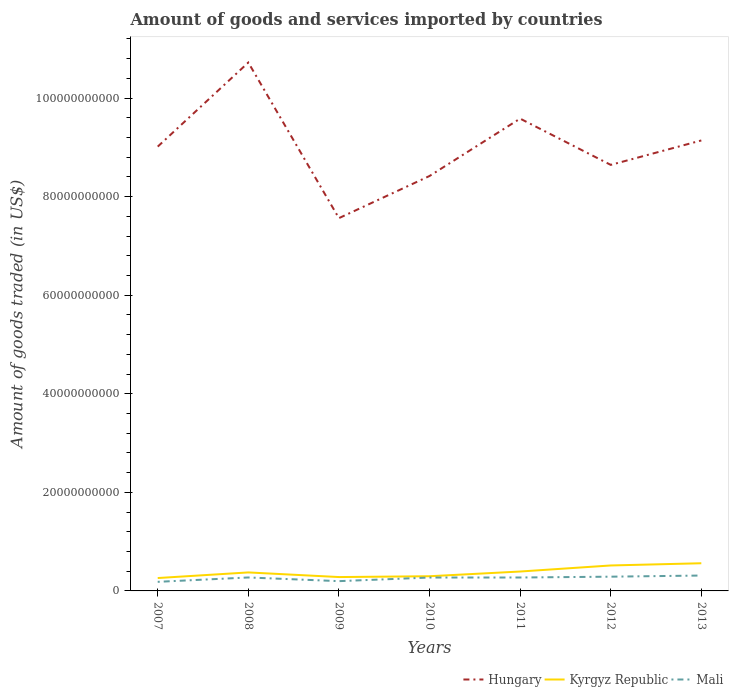How many different coloured lines are there?
Offer a terse response. 3. Does the line corresponding to Kyrgyz Republic intersect with the line corresponding to Mali?
Your response must be concise. No. Is the number of lines equal to the number of legend labels?
Ensure brevity in your answer.  Yes. Across all years, what is the maximum total amount of goods and services imported in Kyrgyz Republic?
Ensure brevity in your answer.  2.61e+09. In which year was the total amount of goods and services imported in Kyrgyz Republic maximum?
Ensure brevity in your answer.  2007. What is the total total amount of goods and services imported in Hungary in the graph?
Offer a very short reply. -1.16e+1. What is the difference between the highest and the second highest total amount of goods and services imported in Mali?
Provide a succinct answer. 1.28e+09. Is the total amount of goods and services imported in Mali strictly greater than the total amount of goods and services imported in Kyrgyz Republic over the years?
Your response must be concise. Yes. How many lines are there?
Provide a short and direct response. 3. What is the difference between two consecutive major ticks on the Y-axis?
Keep it short and to the point. 2.00e+1. Where does the legend appear in the graph?
Your answer should be compact. Bottom right. How are the legend labels stacked?
Provide a succinct answer. Horizontal. What is the title of the graph?
Your answer should be very brief. Amount of goods and services imported by countries. What is the label or title of the X-axis?
Give a very brief answer. Years. What is the label or title of the Y-axis?
Provide a short and direct response. Amount of goods traded (in US$). What is the Amount of goods traded (in US$) of Hungary in 2007?
Ensure brevity in your answer.  9.02e+1. What is the Amount of goods traded (in US$) of Kyrgyz Republic in 2007?
Provide a succinct answer. 2.61e+09. What is the Amount of goods traded (in US$) of Mali in 2007?
Make the answer very short. 1.84e+09. What is the Amount of goods traded (in US$) of Hungary in 2008?
Your answer should be compact. 1.07e+11. What is the Amount of goods traded (in US$) of Kyrgyz Republic in 2008?
Keep it short and to the point. 3.75e+09. What is the Amount of goods traded (in US$) of Mali in 2008?
Offer a terse response. 2.73e+09. What is the Amount of goods traded (in US$) in Hungary in 2009?
Offer a terse response. 7.56e+1. What is the Amount of goods traded (in US$) in Kyrgyz Republic in 2009?
Your answer should be compact. 2.81e+09. What is the Amount of goods traded (in US$) in Mali in 2009?
Your response must be concise. 1.98e+09. What is the Amount of goods traded (in US$) in Hungary in 2010?
Offer a terse response. 8.42e+1. What is the Amount of goods traded (in US$) of Kyrgyz Republic in 2010?
Provide a short and direct response. 2.98e+09. What is the Amount of goods traded (in US$) of Mali in 2010?
Your response must be concise. 2.72e+09. What is the Amount of goods traded (in US$) of Hungary in 2011?
Provide a short and direct response. 9.58e+1. What is the Amount of goods traded (in US$) of Kyrgyz Republic in 2011?
Your answer should be very brief. 3.94e+09. What is the Amount of goods traded (in US$) in Mali in 2011?
Your answer should be very brief. 2.72e+09. What is the Amount of goods traded (in US$) of Hungary in 2012?
Your response must be concise. 8.65e+1. What is the Amount of goods traded (in US$) of Kyrgyz Republic in 2012?
Your answer should be compact. 5.17e+09. What is the Amount of goods traded (in US$) in Mali in 2012?
Make the answer very short. 2.89e+09. What is the Amount of goods traded (in US$) in Hungary in 2013?
Keep it short and to the point. 9.14e+1. What is the Amount of goods traded (in US$) of Kyrgyz Republic in 2013?
Provide a short and direct response. 5.61e+09. What is the Amount of goods traded (in US$) in Mali in 2013?
Your answer should be very brief. 3.12e+09. Across all years, what is the maximum Amount of goods traded (in US$) of Hungary?
Offer a very short reply. 1.07e+11. Across all years, what is the maximum Amount of goods traded (in US$) of Kyrgyz Republic?
Provide a short and direct response. 5.61e+09. Across all years, what is the maximum Amount of goods traded (in US$) of Mali?
Make the answer very short. 3.12e+09. Across all years, what is the minimum Amount of goods traded (in US$) in Hungary?
Offer a terse response. 7.56e+1. Across all years, what is the minimum Amount of goods traded (in US$) in Kyrgyz Republic?
Make the answer very short. 2.61e+09. Across all years, what is the minimum Amount of goods traded (in US$) in Mali?
Make the answer very short. 1.84e+09. What is the total Amount of goods traded (in US$) in Hungary in the graph?
Your answer should be very brief. 6.31e+11. What is the total Amount of goods traded (in US$) in Kyrgyz Republic in the graph?
Offer a very short reply. 2.69e+1. What is the total Amount of goods traded (in US$) of Mali in the graph?
Provide a short and direct response. 1.80e+1. What is the difference between the Amount of goods traded (in US$) in Hungary in 2007 and that in 2008?
Make the answer very short. -1.71e+1. What is the difference between the Amount of goods traded (in US$) of Kyrgyz Republic in 2007 and that in 2008?
Your response must be concise. -1.14e+09. What is the difference between the Amount of goods traded (in US$) in Mali in 2007 and that in 2008?
Offer a very short reply. -8.86e+08. What is the difference between the Amount of goods traded (in US$) of Hungary in 2007 and that in 2009?
Provide a short and direct response. 1.45e+1. What is the difference between the Amount of goods traded (in US$) of Kyrgyz Republic in 2007 and that in 2009?
Your answer should be compact. -2.00e+08. What is the difference between the Amount of goods traded (in US$) of Mali in 2007 and that in 2009?
Provide a succinct answer. -1.38e+08. What is the difference between the Amount of goods traded (in US$) of Hungary in 2007 and that in 2010?
Provide a short and direct response. 5.96e+09. What is the difference between the Amount of goods traded (in US$) in Kyrgyz Republic in 2007 and that in 2010?
Keep it short and to the point. -3.67e+08. What is the difference between the Amount of goods traded (in US$) of Mali in 2007 and that in 2010?
Offer a terse response. -8.73e+08. What is the difference between the Amount of goods traded (in US$) in Hungary in 2007 and that in 2011?
Offer a terse response. -5.68e+09. What is the difference between the Amount of goods traded (in US$) of Kyrgyz Republic in 2007 and that in 2011?
Provide a short and direct response. -1.32e+09. What is the difference between the Amount of goods traded (in US$) of Mali in 2007 and that in 2011?
Make the answer very short. -8.78e+08. What is the difference between the Amount of goods traded (in US$) in Hungary in 2007 and that in 2012?
Make the answer very short. 3.71e+09. What is the difference between the Amount of goods traded (in US$) of Kyrgyz Republic in 2007 and that in 2012?
Offer a very short reply. -2.55e+09. What is the difference between the Amount of goods traded (in US$) of Mali in 2007 and that in 2012?
Provide a short and direct response. -1.04e+09. What is the difference between the Amount of goods traded (in US$) in Hungary in 2007 and that in 2013?
Make the answer very short. -1.25e+09. What is the difference between the Amount of goods traded (in US$) in Kyrgyz Republic in 2007 and that in 2013?
Your response must be concise. -3.00e+09. What is the difference between the Amount of goods traded (in US$) in Mali in 2007 and that in 2013?
Give a very brief answer. -1.28e+09. What is the difference between the Amount of goods traded (in US$) of Hungary in 2008 and that in 2009?
Make the answer very short. 3.16e+1. What is the difference between the Amount of goods traded (in US$) of Kyrgyz Republic in 2008 and that in 2009?
Make the answer very short. 9.40e+08. What is the difference between the Amount of goods traded (in US$) in Mali in 2008 and that in 2009?
Ensure brevity in your answer.  7.48e+08. What is the difference between the Amount of goods traded (in US$) of Hungary in 2008 and that in 2010?
Offer a terse response. 2.30e+1. What is the difference between the Amount of goods traded (in US$) in Kyrgyz Republic in 2008 and that in 2010?
Provide a succinct answer. 7.73e+08. What is the difference between the Amount of goods traded (in US$) in Mali in 2008 and that in 2010?
Offer a very short reply. 1.33e+07. What is the difference between the Amount of goods traded (in US$) of Hungary in 2008 and that in 2011?
Ensure brevity in your answer.  1.14e+1. What is the difference between the Amount of goods traded (in US$) in Kyrgyz Republic in 2008 and that in 2011?
Provide a succinct answer. -1.82e+08. What is the difference between the Amount of goods traded (in US$) in Mali in 2008 and that in 2011?
Provide a short and direct response. 7.92e+06. What is the difference between the Amount of goods traded (in US$) in Hungary in 2008 and that in 2012?
Keep it short and to the point. 2.08e+1. What is the difference between the Amount of goods traded (in US$) of Kyrgyz Republic in 2008 and that in 2012?
Keep it short and to the point. -1.41e+09. What is the difference between the Amount of goods traded (in US$) of Mali in 2008 and that in 2012?
Your answer should be compact. -1.59e+08. What is the difference between the Amount of goods traded (in US$) in Hungary in 2008 and that in 2013?
Provide a succinct answer. 1.58e+1. What is the difference between the Amount of goods traded (in US$) of Kyrgyz Republic in 2008 and that in 2013?
Give a very brief answer. -1.86e+09. What is the difference between the Amount of goods traded (in US$) of Mali in 2008 and that in 2013?
Your response must be concise. -3.91e+08. What is the difference between the Amount of goods traded (in US$) of Hungary in 2009 and that in 2010?
Offer a very short reply. -8.55e+09. What is the difference between the Amount of goods traded (in US$) of Kyrgyz Republic in 2009 and that in 2010?
Keep it short and to the point. -1.67e+08. What is the difference between the Amount of goods traded (in US$) in Mali in 2009 and that in 2010?
Ensure brevity in your answer.  -7.35e+08. What is the difference between the Amount of goods traded (in US$) in Hungary in 2009 and that in 2011?
Keep it short and to the point. -2.02e+1. What is the difference between the Amount of goods traded (in US$) of Kyrgyz Republic in 2009 and that in 2011?
Keep it short and to the point. -1.12e+09. What is the difference between the Amount of goods traded (in US$) in Mali in 2009 and that in 2011?
Make the answer very short. -7.40e+08. What is the difference between the Amount of goods traded (in US$) of Hungary in 2009 and that in 2012?
Provide a short and direct response. -1.08e+1. What is the difference between the Amount of goods traded (in US$) in Kyrgyz Republic in 2009 and that in 2012?
Give a very brief answer. -2.35e+09. What is the difference between the Amount of goods traded (in US$) of Mali in 2009 and that in 2012?
Offer a very short reply. -9.07e+08. What is the difference between the Amount of goods traded (in US$) of Hungary in 2009 and that in 2013?
Your answer should be compact. -1.58e+1. What is the difference between the Amount of goods traded (in US$) in Kyrgyz Republic in 2009 and that in 2013?
Your answer should be very brief. -2.80e+09. What is the difference between the Amount of goods traded (in US$) of Mali in 2009 and that in 2013?
Provide a short and direct response. -1.14e+09. What is the difference between the Amount of goods traded (in US$) of Hungary in 2010 and that in 2011?
Make the answer very short. -1.16e+1. What is the difference between the Amount of goods traded (in US$) in Kyrgyz Republic in 2010 and that in 2011?
Ensure brevity in your answer.  -9.55e+08. What is the difference between the Amount of goods traded (in US$) of Mali in 2010 and that in 2011?
Provide a succinct answer. -5.41e+06. What is the difference between the Amount of goods traded (in US$) of Hungary in 2010 and that in 2012?
Your answer should be very brief. -2.26e+09. What is the difference between the Amount of goods traded (in US$) of Kyrgyz Republic in 2010 and that in 2012?
Offer a very short reply. -2.18e+09. What is the difference between the Amount of goods traded (in US$) of Mali in 2010 and that in 2012?
Offer a terse response. -1.72e+08. What is the difference between the Amount of goods traded (in US$) in Hungary in 2010 and that in 2013?
Keep it short and to the point. -7.21e+09. What is the difference between the Amount of goods traded (in US$) of Kyrgyz Republic in 2010 and that in 2013?
Provide a succinct answer. -2.63e+09. What is the difference between the Amount of goods traded (in US$) in Mali in 2010 and that in 2013?
Provide a succinct answer. -4.05e+08. What is the difference between the Amount of goods traded (in US$) in Hungary in 2011 and that in 2012?
Provide a succinct answer. 9.39e+09. What is the difference between the Amount of goods traded (in US$) of Kyrgyz Republic in 2011 and that in 2012?
Ensure brevity in your answer.  -1.23e+09. What is the difference between the Amount of goods traded (in US$) of Mali in 2011 and that in 2012?
Provide a short and direct response. -1.67e+08. What is the difference between the Amount of goods traded (in US$) of Hungary in 2011 and that in 2013?
Give a very brief answer. 4.43e+09. What is the difference between the Amount of goods traded (in US$) in Kyrgyz Republic in 2011 and that in 2013?
Provide a short and direct response. -1.68e+09. What is the difference between the Amount of goods traded (in US$) in Mali in 2011 and that in 2013?
Your answer should be compact. -3.99e+08. What is the difference between the Amount of goods traded (in US$) of Hungary in 2012 and that in 2013?
Ensure brevity in your answer.  -4.96e+09. What is the difference between the Amount of goods traded (in US$) of Kyrgyz Republic in 2012 and that in 2013?
Give a very brief answer. -4.49e+08. What is the difference between the Amount of goods traded (in US$) of Mali in 2012 and that in 2013?
Your answer should be very brief. -2.32e+08. What is the difference between the Amount of goods traded (in US$) of Hungary in 2007 and the Amount of goods traded (in US$) of Kyrgyz Republic in 2008?
Your answer should be very brief. 8.64e+1. What is the difference between the Amount of goods traded (in US$) of Hungary in 2007 and the Amount of goods traded (in US$) of Mali in 2008?
Offer a very short reply. 8.74e+1. What is the difference between the Amount of goods traded (in US$) of Kyrgyz Republic in 2007 and the Amount of goods traded (in US$) of Mali in 2008?
Your answer should be compact. -1.17e+08. What is the difference between the Amount of goods traded (in US$) in Hungary in 2007 and the Amount of goods traded (in US$) in Kyrgyz Republic in 2009?
Your answer should be very brief. 8.73e+1. What is the difference between the Amount of goods traded (in US$) in Hungary in 2007 and the Amount of goods traded (in US$) in Mali in 2009?
Give a very brief answer. 8.82e+1. What is the difference between the Amount of goods traded (in US$) of Kyrgyz Republic in 2007 and the Amount of goods traded (in US$) of Mali in 2009?
Your response must be concise. 6.31e+08. What is the difference between the Amount of goods traded (in US$) in Hungary in 2007 and the Amount of goods traded (in US$) in Kyrgyz Republic in 2010?
Keep it short and to the point. 8.72e+1. What is the difference between the Amount of goods traded (in US$) in Hungary in 2007 and the Amount of goods traded (in US$) in Mali in 2010?
Your response must be concise. 8.74e+1. What is the difference between the Amount of goods traded (in US$) of Kyrgyz Republic in 2007 and the Amount of goods traded (in US$) of Mali in 2010?
Your answer should be compact. -1.04e+08. What is the difference between the Amount of goods traded (in US$) in Hungary in 2007 and the Amount of goods traded (in US$) in Kyrgyz Republic in 2011?
Give a very brief answer. 8.62e+1. What is the difference between the Amount of goods traded (in US$) of Hungary in 2007 and the Amount of goods traded (in US$) of Mali in 2011?
Provide a short and direct response. 8.74e+1. What is the difference between the Amount of goods traded (in US$) in Kyrgyz Republic in 2007 and the Amount of goods traded (in US$) in Mali in 2011?
Your answer should be very brief. -1.09e+08. What is the difference between the Amount of goods traded (in US$) of Hungary in 2007 and the Amount of goods traded (in US$) of Kyrgyz Republic in 2012?
Your response must be concise. 8.50e+1. What is the difference between the Amount of goods traded (in US$) in Hungary in 2007 and the Amount of goods traded (in US$) in Mali in 2012?
Ensure brevity in your answer.  8.73e+1. What is the difference between the Amount of goods traded (in US$) in Kyrgyz Republic in 2007 and the Amount of goods traded (in US$) in Mali in 2012?
Provide a short and direct response. -2.76e+08. What is the difference between the Amount of goods traded (in US$) in Hungary in 2007 and the Amount of goods traded (in US$) in Kyrgyz Republic in 2013?
Give a very brief answer. 8.45e+1. What is the difference between the Amount of goods traded (in US$) in Hungary in 2007 and the Amount of goods traded (in US$) in Mali in 2013?
Provide a succinct answer. 8.70e+1. What is the difference between the Amount of goods traded (in US$) in Kyrgyz Republic in 2007 and the Amount of goods traded (in US$) in Mali in 2013?
Offer a terse response. -5.08e+08. What is the difference between the Amount of goods traded (in US$) of Hungary in 2008 and the Amount of goods traded (in US$) of Kyrgyz Republic in 2009?
Offer a very short reply. 1.04e+11. What is the difference between the Amount of goods traded (in US$) in Hungary in 2008 and the Amount of goods traded (in US$) in Mali in 2009?
Offer a terse response. 1.05e+11. What is the difference between the Amount of goods traded (in US$) of Kyrgyz Republic in 2008 and the Amount of goods traded (in US$) of Mali in 2009?
Keep it short and to the point. 1.77e+09. What is the difference between the Amount of goods traded (in US$) in Hungary in 2008 and the Amount of goods traded (in US$) in Kyrgyz Republic in 2010?
Ensure brevity in your answer.  1.04e+11. What is the difference between the Amount of goods traded (in US$) of Hungary in 2008 and the Amount of goods traded (in US$) of Mali in 2010?
Provide a short and direct response. 1.04e+11. What is the difference between the Amount of goods traded (in US$) in Kyrgyz Republic in 2008 and the Amount of goods traded (in US$) in Mali in 2010?
Offer a terse response. 1.04e+09. What is the difference between the Amount of goods traded (in US$) in Hungary in 2008 and the Amount of goods traded (in US$) in Kyrgyz Republic in 2011?
Ensure brevity in your answer.  1.03e+11. What is the difference between the Amount of goods traded (in US$) in Hungary in 2008 and the Amount of goods traded (in US$) in Mali in 2011?
Offer a terse response. 1.04e+11. What is the difference between the Amount of goods traded (in US$) of Kyrgyz Republic in 2008 and the Amount of goods traded (in US$) of Mali in 2011?
Offer a terse response. 1.03e+09. What is the difference between the Amount of goods traded (in US$) of Hungary in 2008 and the Amount of goods traded (in US$) of Kyrgyz Republic in 2012?
Offer a very short reply. 1.02e+11. What is the difference between the Amount of goods traded (in US$) in Hungary in 2008 and the Amount of goods traded (in US$) in Mali in 2012?
Provide a short and direct response. 1.04e+11. What is the difference between the Amount of goods traded (in US$) of Kyrgyz Republic in 2008 and the Amount of goods traded (in US$) of Mali in 2012?
Provide a short and direct response. 8.64e+08. What is the difference between the Amount of goods traded (in US$) of Hungary in 2008 and the Amount of goods traded (in US$) of Kyrgyz Republic in 2013?
Keep it short and to the point. 1.02e+11. What is the difference between the Amount of goods traded (in US$) in Hungary in 2008 and the Amount of goods traded (in US$) in Mali in 2013?
Provide a short and direct response. 1.04e+11. What is the difference between the Amount of goods traded (in US$) of Kyrgyz Republic in 2008 and the Amount of goods traded (in US$) of Mali in 2013?
Give a very brief answer. 6.32e+08. What is the difference between the Amount of goods traded (in US$) in Hungary in 2009 and the Amount of goods traded (in US$) in Kyrgyz Republic in 2010?
Your response must be concise. 7.27e+1. What is the difference between the Amount of goods traded (in US$) of Hungary in 2009 and the Amount of goods traded (in US$) of Mali in 2010?
Offer a terse response. 7.29e+1. What is the difference between the Amount of goods traded (in US$) in Kyrgyz Republic in 2009 and the Amount of goods traded (in US$) in Mali in 2010?
Offer a terse response. 9.64e+07. What is the difference between the Amount of goods traded (in US$) of Hungary in 2009 and the Amount of goods traded (in US$) of Kyrgyz Republic in 2011?
Give a very brief answer. 7.17e+1. What is the difference between the Amount of goods traded (in US$) in Hungary in 2009 and the Amount of goods traded (in US$) in Mali in 2011?
Make the answer very short. 7.29e+1. What is the difference between the Amount of goods traded (in US$) of Kyrgyz Republic in 2009 and the Amount of goods traded (in US$) of Mali in 2011?
Your answer should be very brief. 9.10e+07. What is the difference between the Amount of goods traded (in US$) in Hungary in 2009 and the Amount of goods traded (in US$) in Kyrgyz Republic in 2012?
Ensure brevity in your answer.  7.05e+1. What is the difference between the Amount of goods traded (in US$) of Hungary in 2009 and the Amount of goods traded (in US$) of Mali in 2012?
Provide a short and direct response. 7.28e+1. What is the difference between the Amount of goods traded (in US$) of Kyrgyz Republic in 2009 and the Amount of goods traded (in US$) of Mali in 2012?
Keep it short and to the point. -7.59e+07. What is the difference between the Amount of goods traded (in US$) in Hungary in 2009 and the Amount of goods traded (in US$) in Kyrgyz Republic in 2013?
Ensure brevity in your answer.  7.00e+1. What is the difference between the Amount of goods traded (in US$) in Hungary in 2009 and the Amount of goods traded (in US$) in Mali in 2013?
Offer a terse response. 7.25e+1. What is the difference between the Amount of goods traded (in US$) in Kyrgyz Republic in 2009 and the Amount of goods traded (in US$) in Mali in 2013?
Your response must be concise. -3.08e+08. What is the difference between the Amount of goods traded (in US$) of Hungary in 2010 and the Amount of goods traded (in US$) of Kyrgyz Republic in 2011?
Give a very brief answer. 8.03e+1. What is the difference between the Amount of goods traded (in US$) in Hungary in 2010 and the Amount of goods traded (in US$) in Mali in 2011?
Your response must be concise. 8.15e+1. What is the difference between the Amount of goods traded (in US$) in Kyrgyz Republic in 2010 and the Amount of goods traded (in US$) in Mali in 2011?
Provide a succinct answer. 2.58e+08. What is the difference between the Amount of goods traded (in US$) of Hungary in 2010 and the Amount of goods traded (in US$) of Kyrgyz Republic in 2012?
Make the answer very short. 7.90e+1. What is the difference between the Amount of goods traded (in US$) in Hungary in 2010 and the Amount of goods traded (in US$) in Mali in 2012?
Give a very brief answer. 8.13e+1. What is the difference between the Amount of goods traded (in US$) in Kyrgyz Republic in 2010 and the Amount of goods traded (in US$) in Mali in 2012?
Offer a very short reply. 9.14e+07. What is the difference between the Amount of goods traded (in US$) of Hungary in 2010 and the Amount of goods traded (in US$) of Kyrgyz Republic in 2013?
Provide a succinct answer. 7.86e+1. What is the difference between the Amount of goods traded (in US$) of Hungary in 2010 and the Amount of goods traded (in US$) of Mali in 2013?
Offer a terse response. 8.11e+1. What is the difference between the Amount of goods traded (in US$) in Kyrgyz Republic in 2010 and the Amount of goods traded (in US$) in Mali in 2013?
Your answer should be compact. -1.41e+08. What is the difference between the Amount of goods traded (in US$) in Hungary in 2011 and the Amount of goods traded (in US$) in Kyrgyz Republic in 2012?
Offer a terse response. 9.07e+1. What is the difference between the Amount of goods traded (in US$) of Hungary in 2011 and the Amount of goods traded (in US$) of Mali in 2012?
Give a very brief answer. 9.29e+1. What is the difference between the Amount of goods traded (in US$) of Kyrgyz Republic in 2011 and the Amount of goods traded (in US$) of Mali in 2012?
Make the answer very short. 1.05e+09. What is the difference between the Amount of goods traded (in US$) of Hungary in 2011 and the Amount of goods traded (in US$) of Kyrgyz Republic in 2013?
Make the answer very short. 9.02e+1. What is the difference between the Amount of goods traded (in US$) in Hungary in 2011 and the Amount of goods traded (in US$) in Mali in 2013?
Your response must be concise. 9.27e+1. What is the difference between the Amount of goods traded (in US$) of Kyrgyz Republic in 2011 and the Amount of goods traded (in US$) of Mali in 2013?
Provide a short and direct response. 8.14e+08. What is the difference between the Amount of goods traded (in US$) of Hungary in 2012 and the Amount of goods traded (in US$) of Kyrgyz Republic in 2013?
Give a very brief answer. 8.08e+1. What is the difference between the Amount of goods traded (in US$) of Hungary in 2012 and the Amount of goods traded (in US$) of Mali in 2013?
Make the answer very short. 8.33e+1. What is the difference between the Amount of goods traded (in US$) in Kyrgyz Republic in 2012 and the Amount of goods traded (in US$) in Mali in 2013?
Your answer should be compact. 2.04e+09. What is the average Amount of goods traded (in US$) in Hungary per year?
Give a very brief answer. 9.01e+1. What is the average Amount of goods traded (in US$) in Kyrgyz Republic per year?
Give a very brief answer. 3.84e+09. What is the average Amount of goods traded (in US$) in Mali per year?
Provide a short and direct response. 2.57e+09. In the year 2007, what is the difference between the Amount of goods traded (in US$) of Hungary and Amount of goods traded (in US$) of Kyrgyz Republic?
Make the answer very short. 8.75e+1. In the year 2007, what is the difference between the Amount of goods traded (in US$) of Hungary and Amount of goods traded (in US$) of Mali?
Your answer should be very brief. 8.83e+1. In the year 2007, what is the difference between the Amount of goods traded (in US$) in Kyrgyz Republic and Amount of goods traded (in US$) in Mali?
Keep it short and to the point. 7.69e+08. In the year 2008, what is the difference between the Amount of goods traded (in US$) in Hungary and Amount of goods traded (in US$) in Kyrgyz Republic?
Offer a very short reply. 1.03e+11. In the year 2008, what is the difference between the Amount of goods traded (in US$) of Hungary and Amount of goods traded (in US$) of Mali?
Make the answer very short. 1.04e+11. In the year 2008, what is the difference between the Amount of goods traded (in US$) of Kyrgyz Republic and Amount of goods traded (in US$) of Mali?
Your answer should be compact. 1.02e+09. In the year 2009, what is the difference between the Amount of goods traded (in US$) in Hungary and Amount of goods traded (in US$) in Kyrgyz Republic?
Offer a terse response. 7.28e+1. In the year 2009, what is the difference between the Amount of goods traded (in US$) of Hungary and Amount of goods traded (in US$) of Mali?
Your response must be concise. 7.37e+1. In the year 2009, what is the difference between the Amount of goods traded (in US$) of Kyrgyz Republic and Amount of goods traded (in US$) of Mali?
Give a very brief answer. 8.31e+08. In the year 2010, what is the difference between the Amount of goods traded (in US$) of Hungary and Amount of goods traded (in US$) of Kyrgyz Republic?
Your response must be concise. 8.12e+1. In the year 2010, what is the difference between the Amount of goods traded (in US$) of Hungary and Amount of goods traded (in US$) of Mali?
Provide a succinct answer. 8.15e+1. In the year 2010, what is the difference between the Amount of goods traded (in US$) in Kyrgyz Republic and Amount of goods traded (in US$) in Mali?
Offer a very short reply. 2.64e+08. In the year 2011, what is the difference between the Amount of goods traded (in US$) in Hungary and Amount of goods traded (in US$) in Kyrgyz Republic?
Make the answer very short. 9.19e+1. In the year 2011, what is the difference between the Amount of goods traded (in US$) of Hungary and Amount of goods traded (in US$) of Mali?
Ensure brevity in your answer.  9.31e+1. In the year 2011, what is the difference between the Amount of goods traded (in US$) of Kyrgyz Republic and Amount of goods traded (in US$) of Mali?
Make the answer very short. 1.21e+09. In the year 2012, what is the difference between the Amount of goods traded (in US$) of Hungary and Amount of goods traded (in US$) of Kyrgyz Republic?
Your answer should be very brief. 8.13e+1. In the year 2012, what is the difference between the Amount of goods traded (in US$) of Hungary and Amount of goods traded (in US$) of Mali?
Offer a very short reply. 8.36e+1. In the year 2012, what is the difference between the Amount of goods traded (in US$) in Kyrgyz Republic and Amount of goods traded (in US$) in Mali?
Provide a short and direct response. 2.28e+09. In the year 2013, what is the difference between the Amount of goods traded (in US$) of Hungary and Amount of goods traded (in US$) of Kyrgyz Republic?
Give a very brief answer. 8.58e+1. In the year 2013, what is the difference between the Amount of goods traded (in US$) of Hungary and Amount of goods traded (in US$) of Mali?
Offer a terse response. 8.83e+1. In the year 2013, what is the difference between the Amount of goods traded (in US$) in Kyrgyz Republic and Amount of goods traded (in US$) in Mali?
Keep it short and to the point. 2.49e+09. What is the ratio of the Amount of goods traded (in US$) of Hungary in 2007 to that in 2008?
Your answer should be very brief. 0.84. What is the ratio of the Amount of goods traded (in US$) in Kyrgyz Republic in 2007 to that in 2008?
Ensure brevity in your answer.  0.7. What is the ratio of the Amount of goods traded (in US$) of Mali in 2007 to that in 2008?
Offer a terse response. 0.68. What is the ratio of the Amount of goods traded (in US$) in Hungary in 2007 to that in 2009?
Keep it short and to the point. 1.19. What is the ratio of the Amount of goods traded (in US$) in Kyrgyz Republic in 2007 to that in 2009?
Your response must be concise. 0.93. What is the ratio of the Amount of goods traded (in US$) in Mali in 2007 to that in 2009?
Provide a succinct answer. 0.93. What is the ratio of the Amount of goods traded (in US$) of Hungary in 2007 to that in 2010?
Provide a succinct answer. 1.07. What is the ratio of the Amount of goods traded (in US$) in Kyrgyz Republic in 2007 to that in 2010?
Your response must be concise. 0.88. What is the ratio of the Amount of goods traded (in US$) of Mali in 2007 to that in 2010?
Offer a very short reply. 0.68. What is the ratio of the Amount of goods traded (in US$) in Hungary in 2007 to that in 2011?
Your response must be concise. 0.94. What is the ratio of the Amount of goods traded (in US$) of Kyrgyz Republic in 2007 to that in 2011?
Offer a very short reply. 0.66. What is the ratio of the Amount of goods traded (in US$) of Mali in 2007 to that in 2011?
Offer a terse response. 0.68. What is the ratio of the Amount of goods traded (in US$) of Hungary in 2007 to that in 2012?
Your answer should be very brief. 1.04. What is the ratio of the Amount of goods traded (in US$) in Kyrgyz Republic in 2007 to that in 2012?
Provide a succinct answer. 0.51. What is the ratio of the Amount of goods traded (in US$) in Mali in 2007 to that in 2012?
Give a very brief answer. 0.64. What is the ratio of the Amount of goods traded (in US$) of Hungary in 2007 to that in 2013?
Keep it short and to the point. 0.99. What is the ratio of the Amount of goods traded (in US$) in Kyrgyz Republic in 2007 to that in 2013?
Offer a terse response. 0.47. What is the ratio of the Amount of goods traded (in US$) of Mali in 2007 to that in 2013?
Your answer should be compact. 0.59. What is the ratio of the Amount of goods traded (in US$) in Hungary in 2008 to that in 2009?
Give a very brief answer. 1.42. What is the ratio of the Amount of goods traded (in US$) in Kyrgyz Republic in 2008 to that in 2009?
Offer a very short reply. 1.33. What is the ratio of the Amount of goods traded (in US$) in Mali in 2008 to that in 2009?
Your answer should be compact. 1.38. What is the ratio of the Amount of goods traded (in US$) of Hungary in 2008 to that in 2010?
Make the answer very short. 1.27. What is the ratio of the Amount of goods traded (in US$) in Kyrgyz Republic in 2008 to that in 2010?
Your answer should be very brief. 1.26. What is the ratio of the Amount of goods traded (in US$) in Mali in 2008 to that in 2010?
Your answer should be compact. 1. What is the ratio of the Amount of goods traded (in US$) in Hungary in 2008 to that in 2011?
Give a very brief answer. 1.12. What is the ratio of the Amount of goods traded (in US$) in Kyrgyz Republic in 2008 to that in 2011?
Give a very brief answer. 0.95. What is the ratio of the Amount of goods traded (in US$) in Hungary in 2008 to that in 2012?
Your answer should be compact. 1.24. What is the ratio of the Amount of goods traded (in US$) of Kyrgyz Republic in 2008 to that in 2012?
Provide a short and direct response. 0.73. What is the ratio of the Amount of goods traded (in US$) of Mali in 2008 to that in 2012?
Make the answer very short. 0.94. What is the ratio of the Amount of goods traded (in US$) of Hungary in 2008 to that in 2013?
Give a very brief answer. 1.17. What is the ratio of the Amount of goods traded (in US$) in Kyrgyz Republic in 2008 to that in 2013?
Keep it short and to the point. 0.67. What is the ratio of the Amount of goods traded (in US$) in Mali in 2008 to that in 2013?
Your response must be concise. 0.87. What is the ratio of the Amount of goods traded (in US$) in Hungary in 2009 to that in 2010?
Provide a short and direct response. 0.9. What is the ratio of the Amount of goods traded (in US$) of Kyrgyz Republic in 2009 to that in 2010?
Give a very brief answer. 0.94. What is the ratio of the Amount of goods traded (in US$) of Mali in 2009 to that in 2010?
Your answer should be very brief. 0.73. What is the ratio of the Amount of goods traded (in US$) in Hungary in 2009 to that in 2011?
Offer a very short reply. 0.79. What is the ratio of the Amount of goods traded (in US$) in Kyrgyz Republic in 2009 to that in 2011?
Provide a succinct answer. 0.71. What is the ratio of the Amount of goods traded (in US$) in Mali in 2009 to that in 2011?
Make the answer very short. 0.73. What is the ratio of the Amount of goods traded (in US$) in Kyrgyz Republic in 2009 to that in 2012?
Keep it short and to the point. 0.54. What is the ratio of the Amount of goods traded (in US$) in Mali in 2009 to that in 2012?
Offer a terse response. 0.69. What is the ratio of the Amount of goods traded (in US$) of Hungary in 2009 to that in 2013?
Offer a very short reply. 0.83. What is the ratio of the Amount of goods traded (in US$) in Kyrgyz Republic in 2009 to that in 2013?
Offer a very short reply. 0.5. What is the ratio of the Amount of goods traded (in US$) of Mali in 2009 to that in 2013?
Provide a succinct answer. 0.64. What is the ratio of the Amount of goods traded (in US$) of Hungary in 2010 to that in 2011?
Provide a succinct answer. 0.88. What is the ratio of the Amount of goods traded (in US$) of Kyrgyz Republic in 2010 to that in 2011?
Keep it short and to the point. 0.76. What is the ratio of the Amount of goods traded (in US$) of Mali in 2010 to that in 2011?
Your answer should be compact. 1. What is the ratio of the Amount of goods traded (in US$) of Hungary in 2010 to that in 2012?
Your response must be concise. 0.97. What is the ratio of the Amount of goods traded (in US$) in Kyrgyz Republic in 2010 to that in 2012?
Give a very brief answer. 0.58. What is the ratio of the Amount of goods traded (in US$) in Mali in 2010 to that in 2012?
Give a very brief answer. 0.94. What is the ratio of the Amount of goods traded (in US$) in Hungary in 2010 to that in 2013?
Your answer should be compact. 0.92. What is the ratio of the Amount of goods traded (in US$) of Kyrgyz Republic in 2010 to that in 2013?
Your response must be concise. 0.53. What is the ratio of the Amount of goods traded (in US$) of Mali in 2010 to that in 2013?
Your response must be concise. 0.87. What is the ratio of the Amount of goods traded (in US$) of Hungary in 2011 to that in 2012?
Make the answer very short. 1.11. What is the ratio of the Amount of goods traded (in US$) in Kyrgyz Republic in 2011 to that in 2012?
Offer a terse response. 0.76. What is the ratio of the Amount of goods traded (in US$) in Mali in 2011 to that in 2012?
Make the answer very short. 0.94. What is the ratio of the Amount of goods traded (in US$) of Hungary in 2011 to that in 2013?
Offer a terse response. 1.05. What is the ratio of the Amount of goods traded (in US$) of Kyrgyz Republic in 2011 to that in 2013?
Offer a terse response. 0.7. What is the ratio of the Amount of goods traded (in US$) in Mali in 2011 to that in 2013?
Your response must be concise. 0.87. What is the ratio of the Amount of goods traded (in US$) in Hungary in 2012 to that in 2013?
Your response must be concise. 0.95. What is the ratio of the Amount of goods traded (in US$) in Kyrgyz Republic in 2012 to that in 2013?
Keep it short and to the point. 0.92. What is the ratio of the Amount of goods traded (in US$) of Mali in 2012 to that in 2013?
Make the answer very short. 0.93. What is the difference between the highest and the second highest Amount of goods traded (in US$) in Hungary?
Offer a terse response. 1.14e+1. What is the difference between the highest and the second highest Amount of goods traded (in US$) of Kyrgyz Republic?
Provide a succinct answer. 4.49e+08. What is the difference between the highest and the second highest Amount of goods traded (in US$) in Mali?
Make the answer very short. 2.32e+08. What is the difference between the highest and the lowest Amount of goods traded (in US$) of Hungary?
Provide a short and direct response. 3.16e+1. What is the difference between the highest and the lowest Amount of goods traded (in US$) in Kyrgyz Republic?
Your answer should be compact. 3.00e+09. What is the difference between the highest and the lowest Amount of goods traded (in US$) in Mali?
Your answer should be compact. 1.28e+09. 